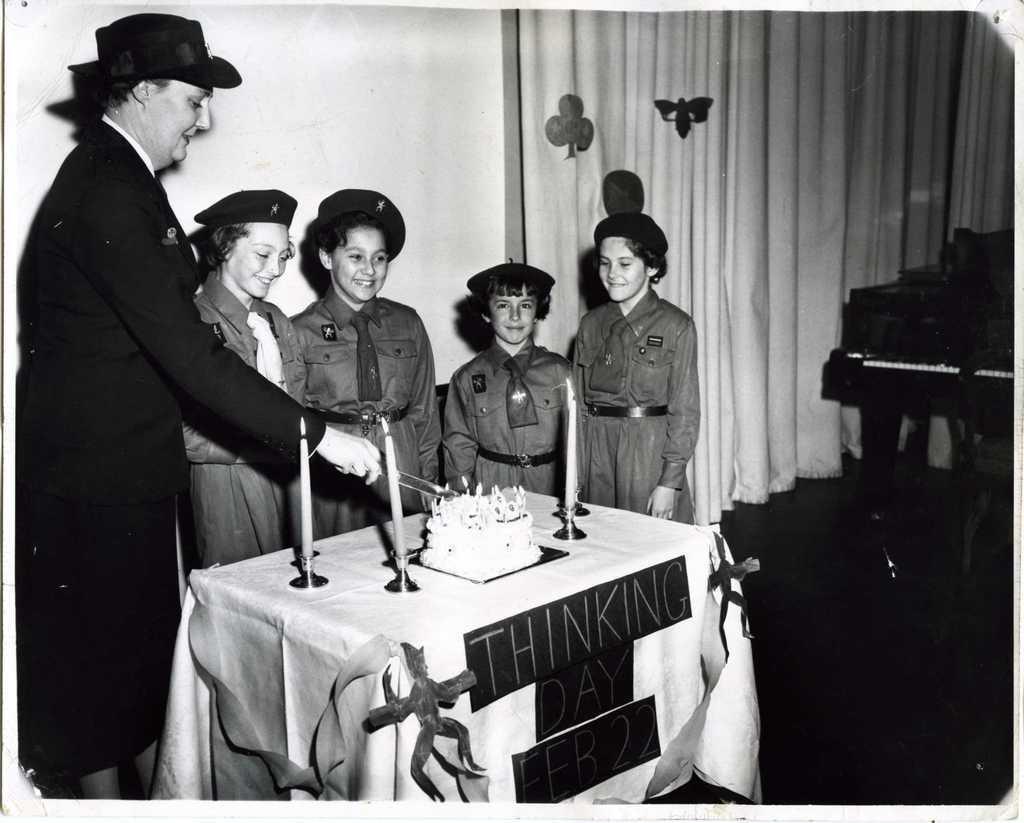In one or two sentences, can you explain what this image depicts? In this image there is a person and few kids are standing behind the table having few candles and a cake are on it. Table is covered with cloth. Candles are lighted. Person wearing a cap is holding a knife in his hand. Beside him there are few kids wearing uniform and they are wearing caps. Right side there is a piano on the floor. Beside there is a curtain. Background there is wall. 